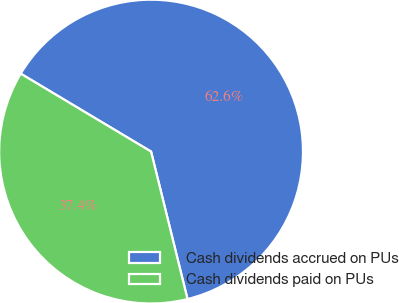Convert chart. <chart><loc_0><loc_0><loc_500><loc_500><pie_chart><fcel>Cash dividends accrued on PUs<fcel>Cash dividends paid on PUs<nl><fcel>62.57%<fcel>37.43%<nl></chart> 